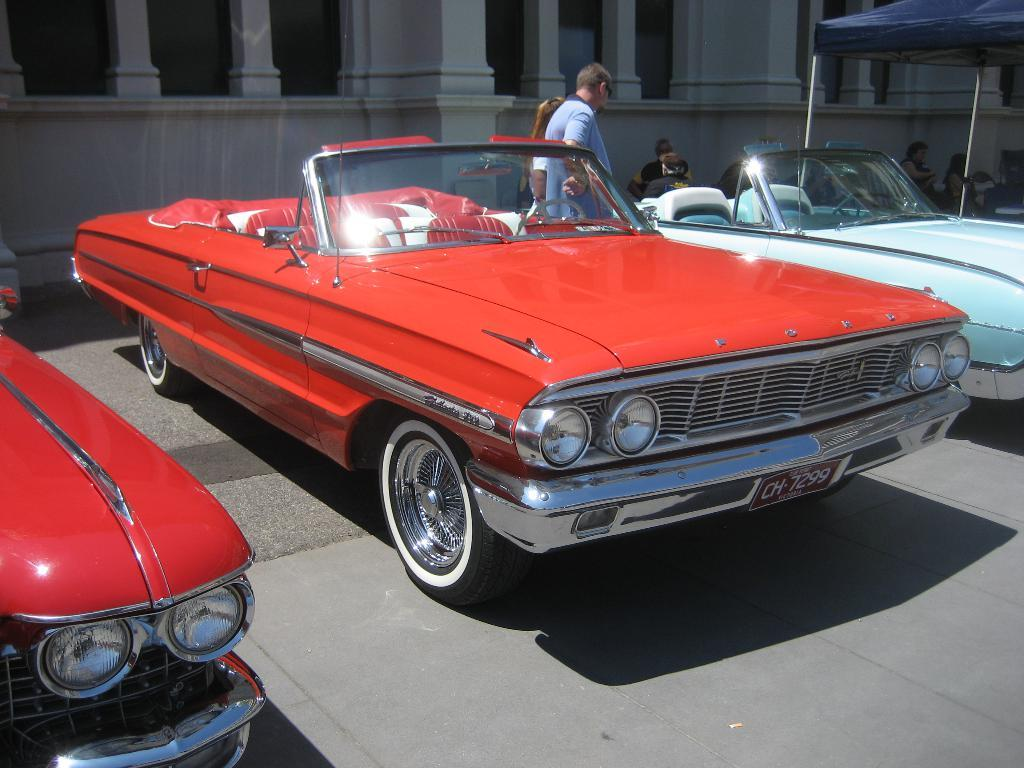What type of vehicles are in the image? There are convertible cars in the image. Who or what is located in the center of the image? A person is standing in the center of the image. What color is the canopy on the right side of the image? There is a blue canopy on the right side of the image. What can be seen in the background of the image? There is a building visible in the background of the image. What type of creature is the person kissing in the image? There is no creature or kissing depicted in the image; it only shows a person standing near convertible cars with a blue canopy and a building in the background. 